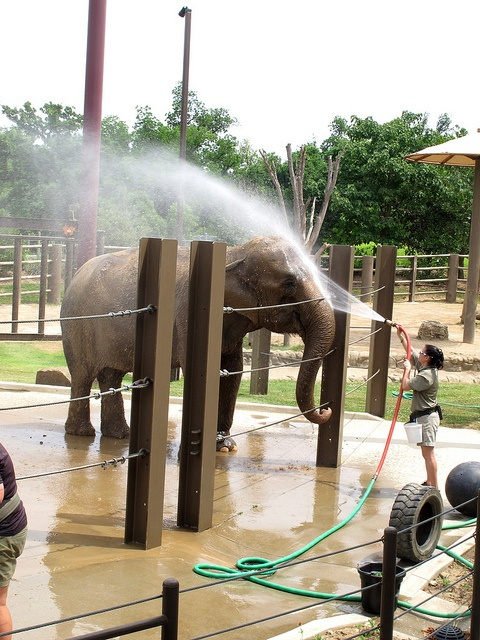Describe the objects in this image and their specific colors. I can see elephant in white, black, gray, and maroon tones, people in white, gray, ivory, and black tones, and people in white, black, and gray tones in this image. 